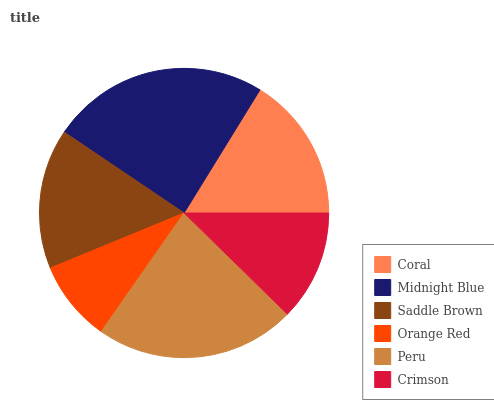Is Orange Red the minimum?
Answer yes or no. Yes. Is Midnight Blue the maximum?
Answer yes or no. Yes. Is Saddle Brown the minimum?
Answer yes or no. No. Is Saddle Brown the maximum?
Answer yes or no. No. Is Midnight Blue greater than Saddle Brown?
Answer yes or no. Yes. Is Saddle Brown less than Midnight Blue?
Answer yes or no. Yes. Is Saddle Brown greater than Midnight Blue?
Answer yes or no. No. Is Midnight Blue less than Saddle Brown?
Answer yes or no. No. Is Coral the high median?
Answer yes or no. Yes. Is Saddle Brown the low median?
Answer yes or no. Yes. Is Saddle Brown the high median?
Answer yes or no. No. Is Orange Red the low median?
Answer yes or no. No. 